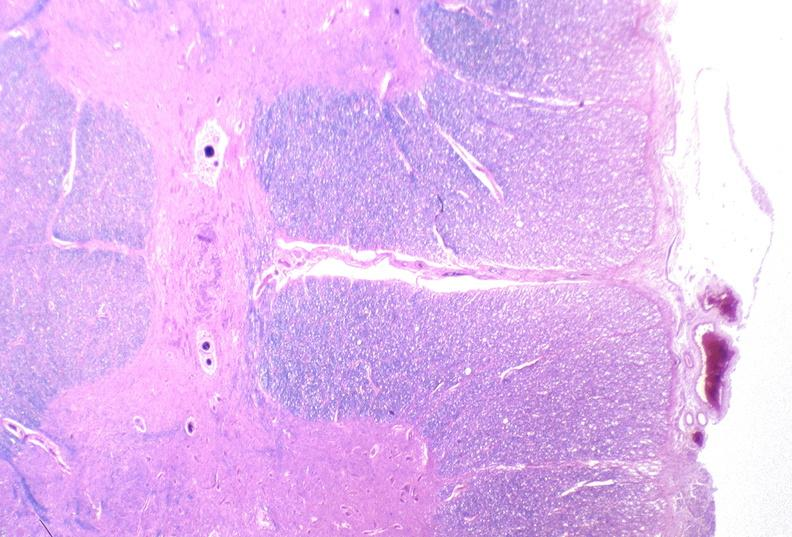s nervous present?
Answer the question using a single word or phrase. Yes 